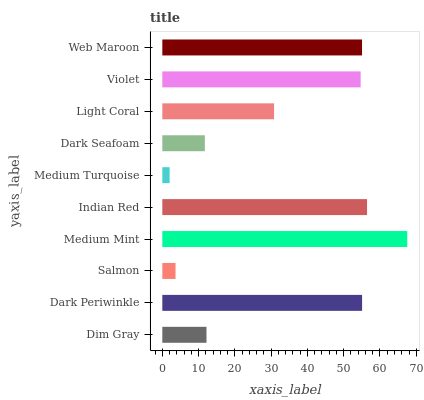Is Medium Turquoise the minimum?
Answer yes or no. Yes. Is Medium Mint the maximum?
Answer yes or no. Yes. Is Dark Periwinkle the minimum?
Answer yes or no. No. Is Dark Periwinkle the maximum?
Answer yes or no. No. Is Dark Periwinkle greater than Dim Gray?
Answer yes or no. Yes. Is Dim Gray less than Dark Periwinkle?
Answer yes or no. Yes. Is Dim Gray greater than Dark Periwinkle?
Answer yes or no. No. Is Dark Periwinkle less than Dim Gray?
Answer yes or no. No. Is Violet the high median?
Answer yes or no. Yes. Is Light Coral the low median?
Answer yes or no. Yes. Is Dark Seafoam the high median?
Answer yes or no. No. Is Violet the low median?
Answer yes or no. No. 